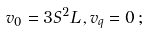<formula> <loc_0><loc_0><loc_500><loc_500>v _ { 0 } = 3 S ^ { 2 } L \, , v _ { q } = 0 \, ;</formula> 